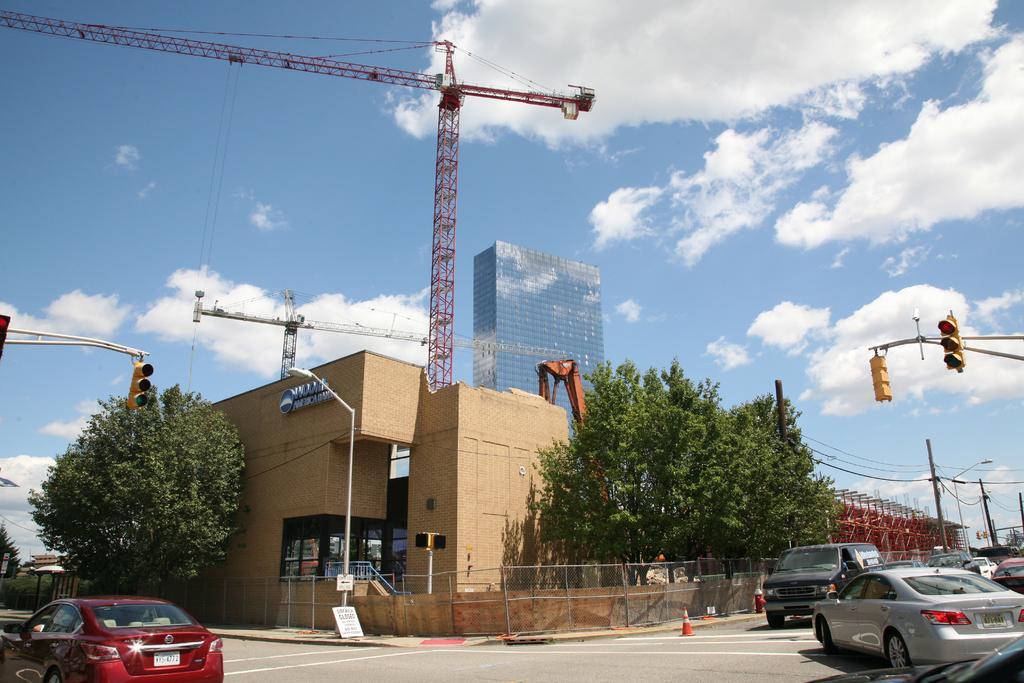Describe this image in one or two sentences. This image is clicked on the road. At the bottom, there is a road. On the left and right, there are cars. In the front, there is a building along with a crane. At the top, there are clouds in the sky. In the background, we can see a skyscraper. On the left, there is a traffic pole. 